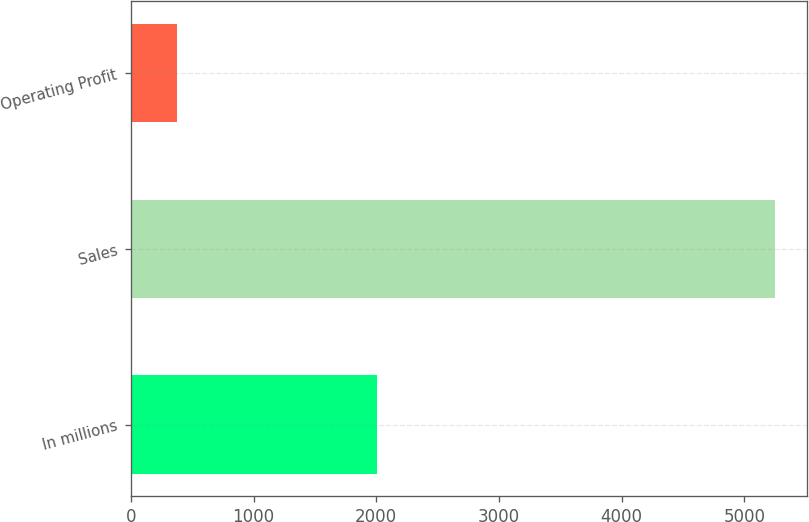<chart> <loc_0><loc_0><loc_500><loc_500><bar_chart><fcel>In millions<fcel>Sales<fcel>Operating Profit<nl><fcel>2007<fcel>5245<fcel>374<nl></chart> 